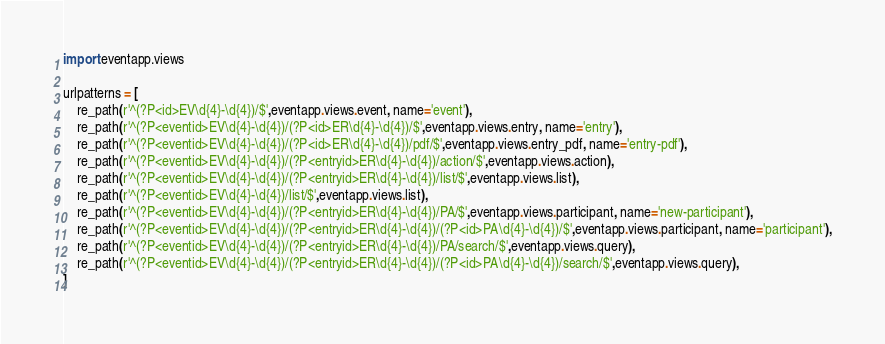Convert code to text. <code><loc_0><loc_0><loc_500><loc_500><_Python_>import eventapp.views

urlpatterns = [
	re_path(r'^(?P<id>EV\d{4}-\d{4})/$',eventapp.views.event, name='event'),
	re_path(r'^(?P<eventid>EV\d{4}-\d{4})/(?P<id>ER\d{4}-\d{4})/$',eventapp.views.entry, name='entry'),
	re_path(r'^(?P<eventid>EV\d{4}-\d{4})/(?P<id>ER\d{4}-\d{4})/pdf/$',eventapp.views.entry_pdf, name='entry-pdf'),
	re_path(r'^(?P<eventid>EV\d{4}-\d{4})/(?P<entryid>ER\d{4}-\d{4})/action/$',eventapp.views.action),
	re_path(r'^(?P<eventid>EV\d{4}-\d{4})/(?P<entryid>ER\d{4}-\d{4})/list/$',eventapp.views.list),
	re_path(r'^(?P<eventid>EV\d{4}-\d{4})/list/$',eventapp.views.list),
	re_path(r'^(?P<eventid>EV\d{4}-\d{4})/(?P<entryid>ER\d{4}-\d{4})/PA/$',eventapp.views.participant, name='new-participant'),
	re_path(r'^(?P<eventid>EV\d{4}-\d{4})/(?P<entryid>ER\d{4}-\d{4})/(?P<id>PA\d{4}-\d{4})/$',eventapp.views.participant, name='participant'),
	re_path(r'^(?P<eventid>EV\d{4}-\d{4})/(?P<entryid>ER\d{4}-\d{4})/PA/search/$',eventapp.views.query),
	re_path(r'^(?P<eventid>EV\d{4}-\d{4})/(?P<entryid>ER\d{4}-\d{4})/(?P<id>PA\d{4}-\d{4})/search/$',eventapp.views.query),
]
</code> 